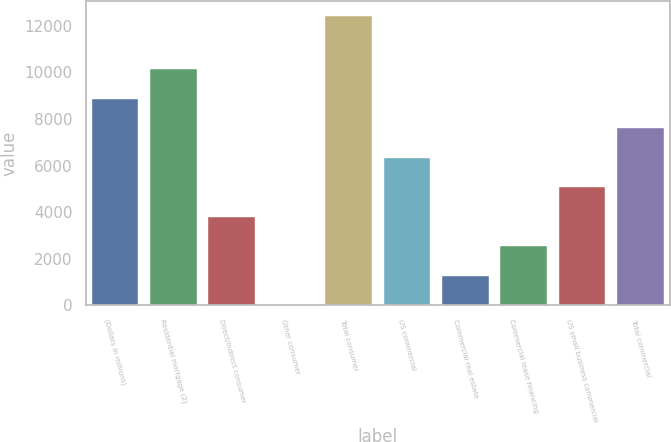Convert chart to OTSL. <chart><loc_0><loc_0><loc_500><loc_500><bar_chart><fcel>(Dollars in millions)<fcel>Residential mortgage (2)<fcel>Direct/Indirect consumer<fcel>Other consumer<fcel>Total consumer<fcel>US commercial<fcel>Commercial real estate<fcel>Commercial lease financing<fcel>US small business commercial<fcel>Total commercial<nl><fcel>8858.1<fcel>10123.4<fcel>3796.9<fcel>1<fcel>12433<fcel>6327.5<fcel>1266.3<fcel>2531.6<fcel>5062.2<fcel>7592.8<nl></chart> 